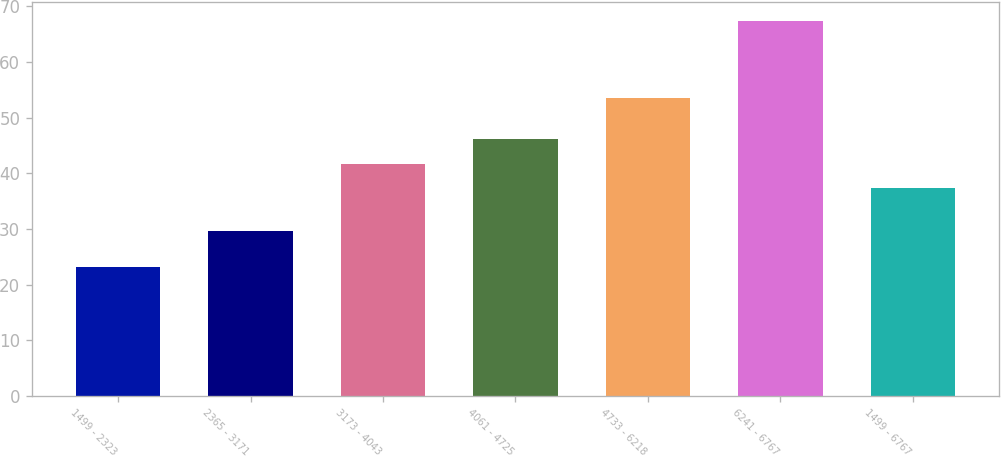Convert chart. <chart><loc_0><loc_0><loc_500><loc_500><bar_chart><fcel>1499 - 2323<fcel>2365 - 3171<fcel>3173 - 4043<fcel>4061 - 4725<fcel>4733 - 6218<fcel>6241 - 6767<fcel>1499 - 6767<nl><fcel>23.1<fcel>29.62<fcel>41.72<fcel>46.16<fcel>53.54<fcel>67.45<fcel>37.28<nl></chart> 